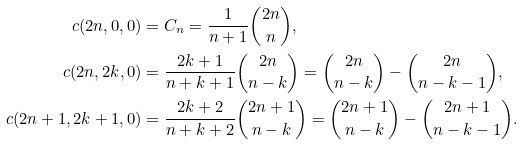Convert formula to latex. <formula><loc_0><loc_0><loc_500><loc_500>c ( 2 n , 0 , 0 ) & = C _ { n } = \frac { 1 } { n + 1 } { 2 n \choose n } , \\ c ( 2 n , 2 k , 0 ) & = \frac { 2 k + 1 } { n + k + 1 } { 2 n \choose n - k } = { 2 n \choose n - k } - { 2 n \choose n - k - 1 } , \\ c ( 2 n + 1 , 2 k + 1 , 0 ) & = \frac { 2 k + 2 } { n + k + 2 } { 2 n + 1 \choose n - k } = { 2 n + 1 \choose n - k } - { 2 n + 1 \choose n - k - 1 } .</formula> 